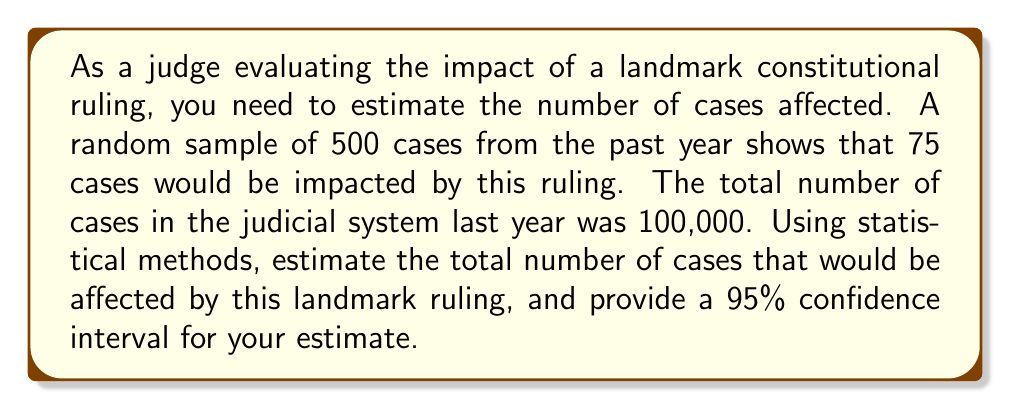What is the answer to this math problem? To estimate the number of cases affected and calculate the confidence interval, we'll follow these steps:

1. Calculate the sample proportion:
   $\hat{p} = \frac{\text{number of affected cases in sample}}{\text{total cases in sample}} = \frac{75}{500} = 0.15$

2. Estimate the total number of affected cases:
   $\text{Estimated total} = \text{Total cases} \times \hat{p} = 100,000 \times 0.15 = 15,000$

3. Calculate the standard error of the proportion:
   $SE(\hat{p}) = \sqrt{\frac{\hat{p}(1-\hat{p})}{n}} = \sqrt{\frac{0.15(1-0.15)}{500}} = 0.01597$

4. For a 95% confidence interval, use z = 1.96 (from the standard normal distribution)

5. Calculate the margin of error:
   $\text{Margin of Error} = z \times SE(\hat{p}) = 1.96 \times 0.01597 = 0.03130$

6. Calculate the confidence interval for the proportion:
   $(\hat{p} - \text{Margin of Error}, \hat{p} + \text{Margin of Error})$
   $(0.15 - 0.03130, 0.15 + 0.03130) = (0.11870, 0.18130)$

7. Convert the confidence interval to the number of cases:
   Lower bound: $100,000 \times 0.11870 = 11,870$
   Upper bound: $100,000 \times 0.18130 = 18,130$

Therefore, we estimate that 15,000 cases would be affected by the landmark ruling, with a 95% confidence interval of (11,870, 18,130) cases.
Answer: 15,000 cases, 95% CI: (11,870, 18,130) 